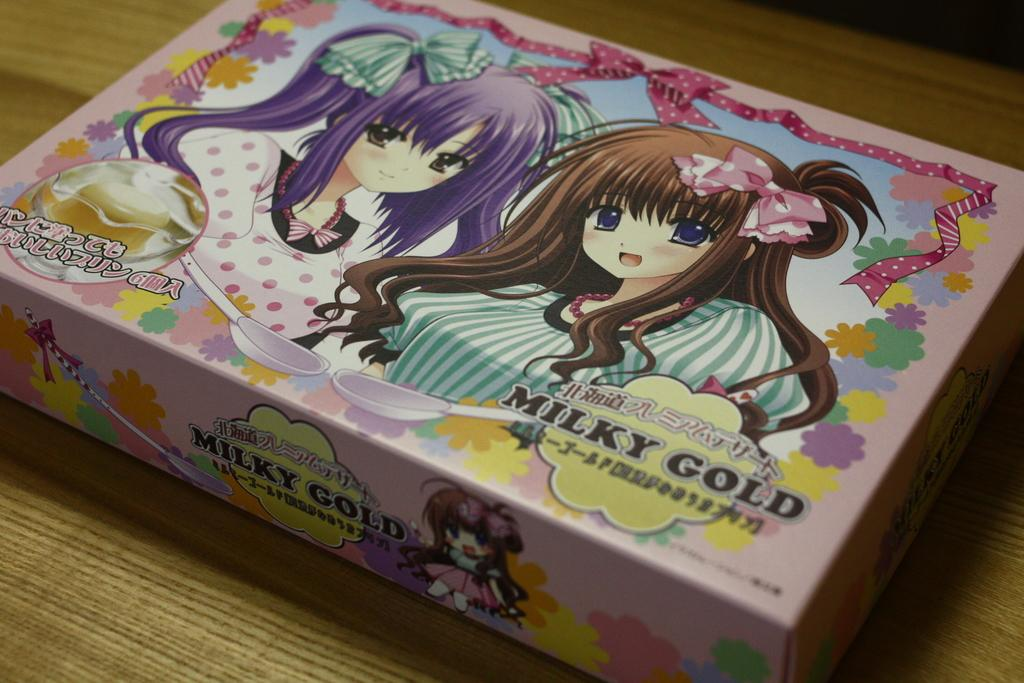What is the main object in the image? There is a box in the image. Can you describe the box cover? The box cover features two girls. What type of carriage can be seen in the image? There is no carriage present in the image; it features a box with two girls on the cover. How many boys are visible in the image? There are no boys visible in the image; it features a box with two girls on the cover. 